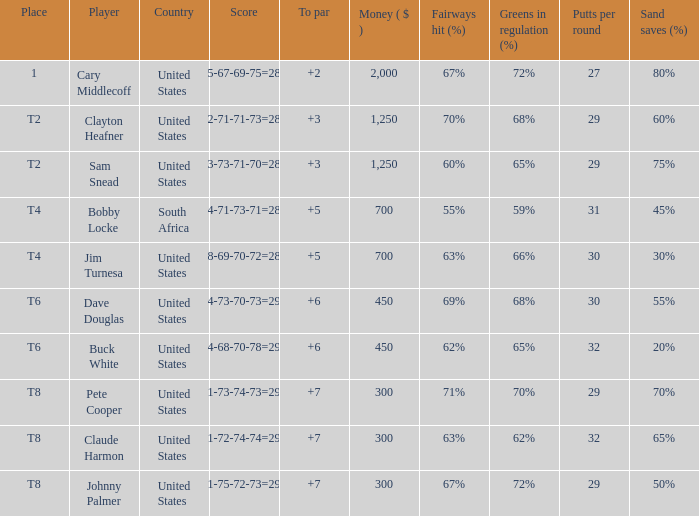What nation does player sam snead, with a to par of under 5, belong to? United States. 